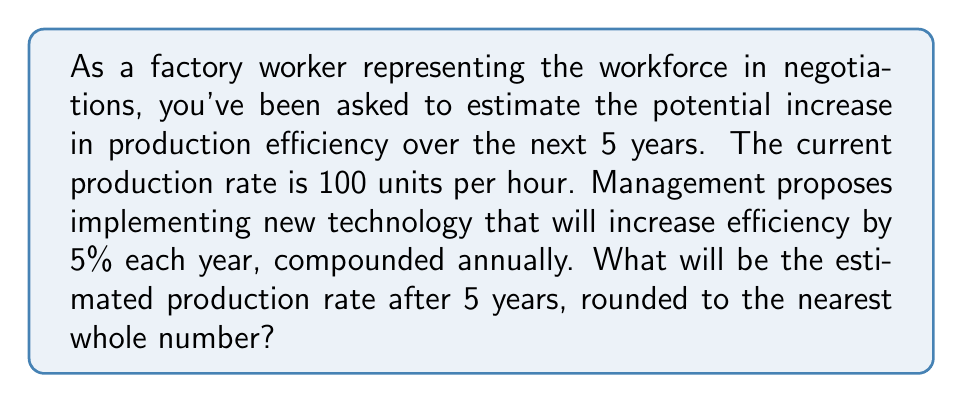Solve this math problem. Let's approach this step-by-step:

1) The initial production rate is 100 units per hour.

2) Each year, the production rate increases by 5% (or 1.05 times the previous year's rate).

3) This continues for 5 years, so we need to compound this growth 5 times.

4) We can represent this mathematically as:

   $$\text{Final Production Rate} = 100 \times (1.05)^5$$

5) Let's calculate this:
   $$\begin{align}
   100 \times (1.05)^5 &= 100 \times 1.2762815625 \\
   &= 127.62815625
   \end{align}$$

6) Rounding to the nearest whole number:
   $$127.62815625 \approx 128$$

Therefore, after 5 years, the estimated production rate will be approximately 128 units per hour.
Answer: 128 units per hour 